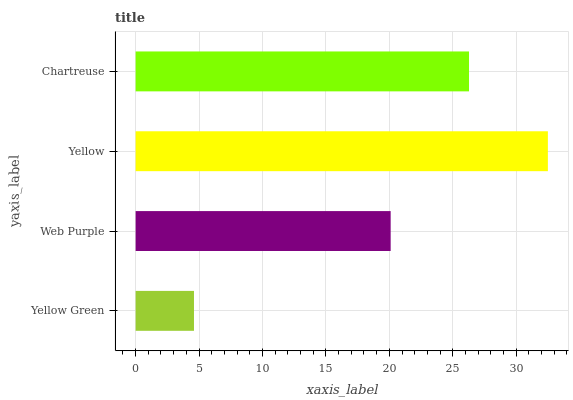Is Yellow Green the minimum?
Answer yes or no. Yes. Is Yellow the maximum?
Answer yes or no. Yes. Is Web Purple the minimum?
Answer yes or no. No. Is Web Purple the maximum?
Answer yes or no. No. Is Web Purple greater than Yellow Green?
Answer yes or no. Yes. Is Yellow Green less than Web Purple?
Answer yes or no. Yes. Is Yellow Green greater than Web Purple?
Answer yes or no. No. Is Web Purple less than Yellow Green?
Answer yes or no. No. Is Chartreuse the high median?
Answer yes or no. Yes. Is Web Purple the low median?
Answer yes or no. Yes. Is Yellow Green the high median?
Answer yes or no. No. Is Chartreuse the low median?
Answer yes or no. No. 